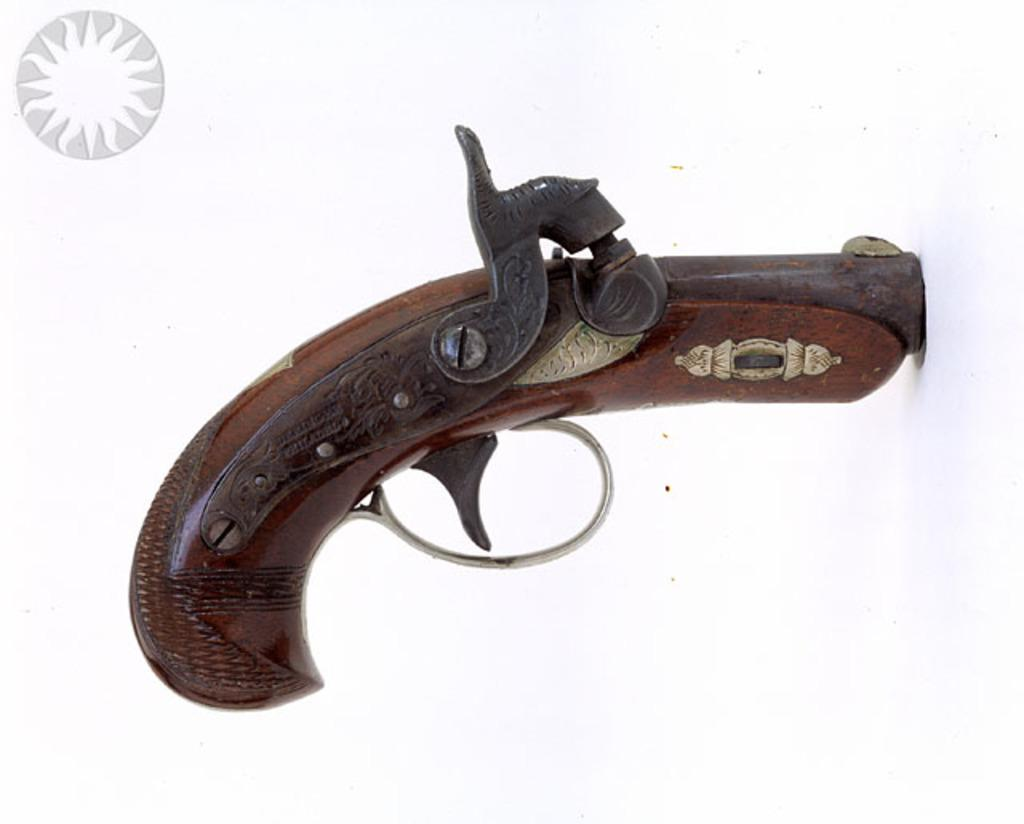What is the main object in the image? There is a gun in the image. Where is the picture located in the image? The picture is at the top left hand side of the image. What color is the background of the image? The background of the image is white in color. What type of square can be seen in the image? There is no square present in the image. What kind of teeth can be seen in the image? There are no teeth visible in the image. 